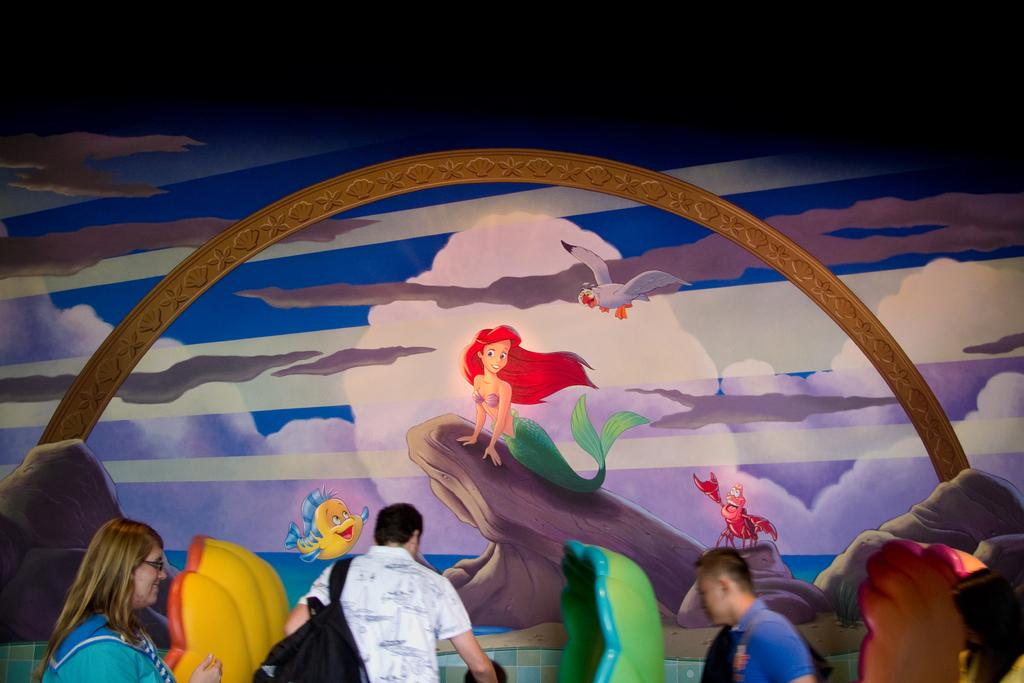What is happening in the image? There are people standing in the image. What can be seen in front of the people? There are two objects in front of the people. What is on the wall in the image? There is a wall with a painting in the image. What type of corn is growing on the trees in the image? There are no trees or corn present in the image. 